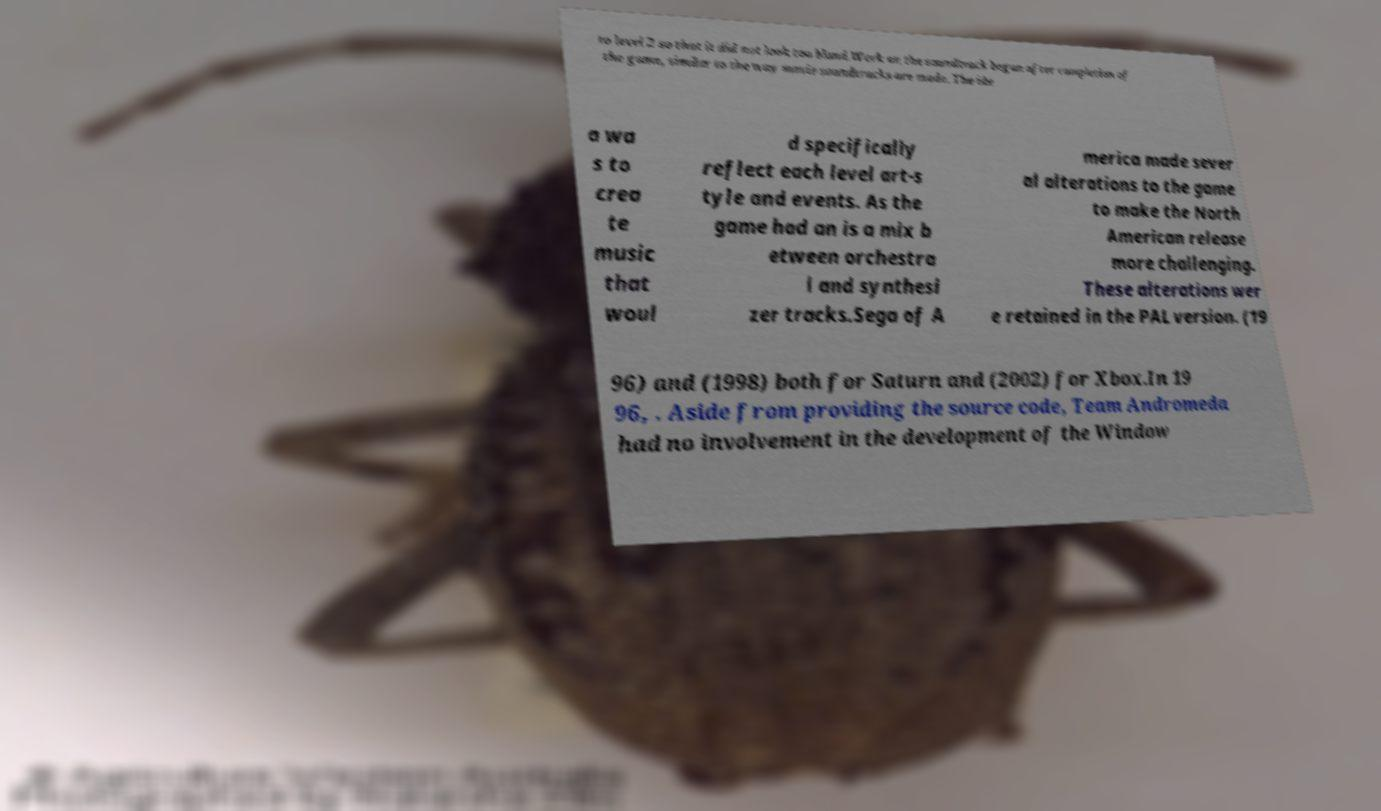Could you assist in decoding the text presented in this image and type it out clearly? to level 2 so that it did not look too bland.Work on the soundtrack began after completion of the game, similar to the way movie soundtracks are made. The ide a wa s to crea te music that woul d specifically reflect each level art-s tyle and events. As the game had an is a mix b etween orchestra l and synthesi zer tracks.Sega of A merica made sever al alterations to the game to make the North American release more challenging. These alterations wer e retained in the PAL version. (19 96) and (1998) both for Saturn and (2002) for Xbox.In 19 96, . Aside from providing the source code, Team Andromeda had no involvement in the development of the Window 